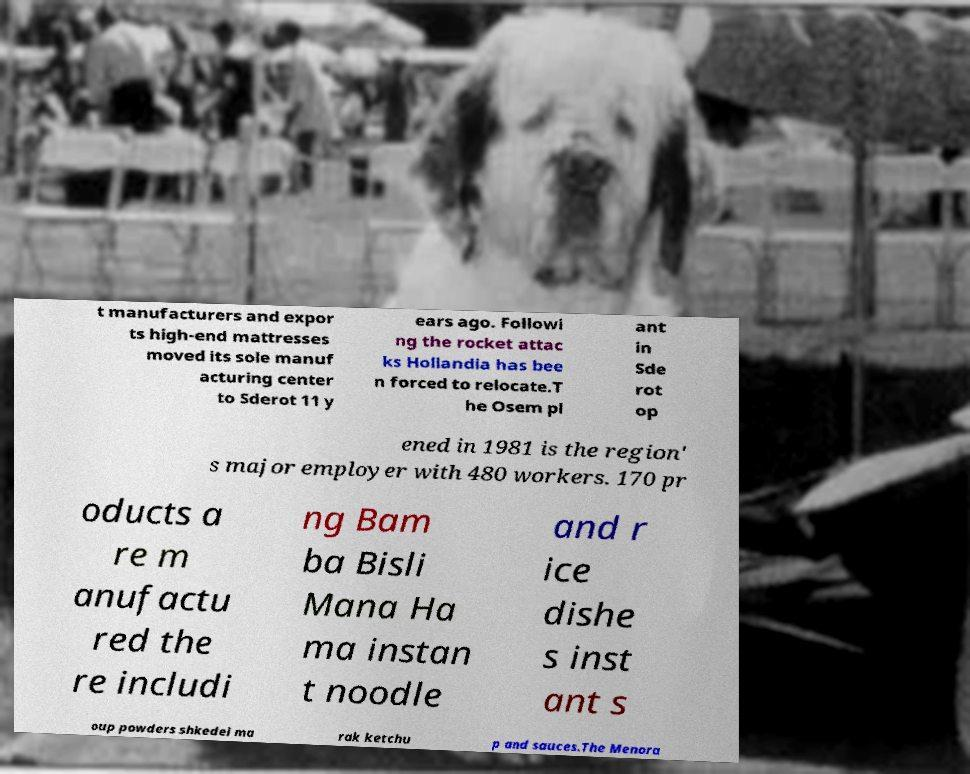There's text embedded in this image that I need extracted. Can you transcribe it verbatim? t manufacturers and expor ts high-end mattresses moved its sole manuf acturing center to Sderot 11 y ears ago. Followi ng the rocket attac ks Hollandia has bee n forced to relocate.T he Osem pl ant in Sde rot op ened in 1981 is the region' s major employer with 480 workers. 170 pr oducts a re m anufactu red the re includi ng Bam ba Bisli Mana Ha ma instan t noodle and r ice dishe s inst ant s oup powders shkedei ma rak ketchu p and sauces.The Menora 